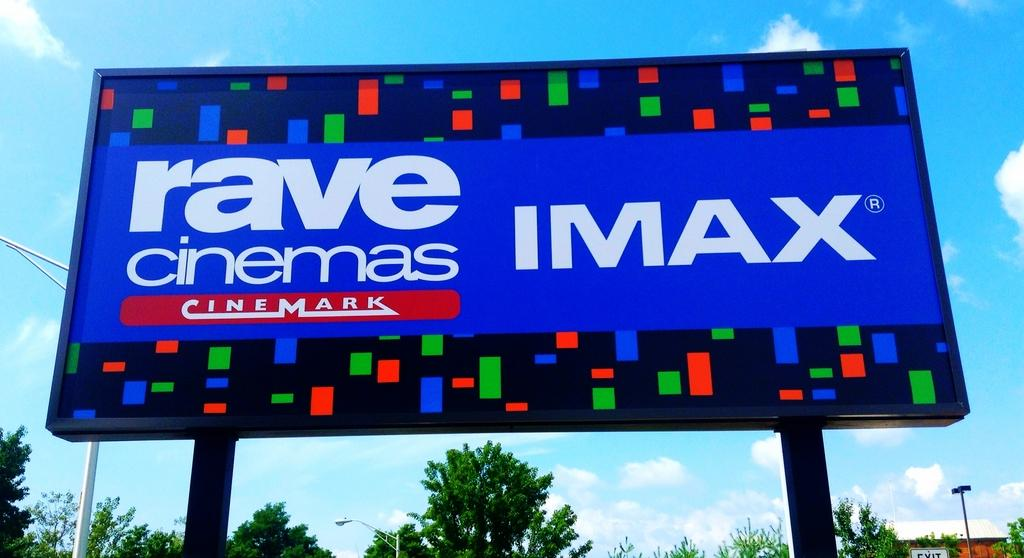What is the color of the hoarding in the image? The hoarding in the image is blue. What is featured on the hoarding besides its color? There is text on the hoarding. What can be seen in the background of the image? There are light poles, trees, a house, and the sky with clouds in the background of the image. What type of silverware is being exchanged in the image? There is no silverware or exchange of items depicted in the image. How many quince are hanging from the trees in the background of the image? There are no quince visible in the image; only trees are present in the background. 